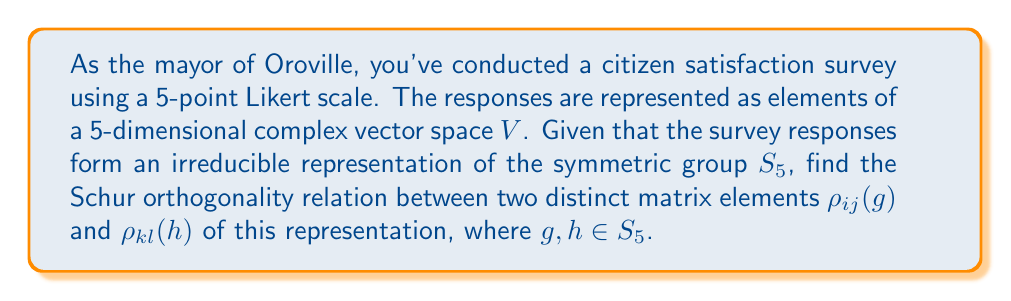Give your solution to this math problem. Let's approach this step-by-step:

1) The Schur orthogonality relations for matrix elements of irreducible representations state that:

   $$\frac{1}{|G|} \sum_{g \in G} \rho_{ij}(g) \overline{\rho_{kl}(g)} = \frac{\delta_{ik}\delta_{jl}}{d_\rho}$$

   where $|G|$ is the order of the group, $d_\rho$ is the dimension of the representation, and $\delta$ is the Kronecker delta.

2) In our case, $G = S_5$, the symmetric group on 5 elements.

3) The order of $S_5$ is $5! = 120$.

4) The dimension of our representation is 5, as we're using a 5-point Likert scale.

5) Since we're asked about distinct matrix elements, $i \neq k$ or $j \neq l$ (or both).

6) Applying the formula:

   $$\frac{1}{120} \sum_{g \in S_5} \rho_{ij}(g) \overline{\rho_{kl}(g)} = \frac{\delta_{ik}\delta_{jl}}{5}$$

7) As the matrix elements are distinct, either $\delta_{ik} = 0$ or $\delta_{jl} = 0$ (or both), so the right-hand side equals 0.

Therefore, the Schur orthogonality relation for distinct matrix elements in this case is:

$$\frac{1}{120} \sum_{g \in S_5} \rho_{ij}(g) \overline{\rho_{kl}(g)} = 0$$
Answer: $$\frac{1}{120} \sum_{g \in S_5} \rho_{ij}(g) \overline{\rho_{kl}(g)} = 0$$ 